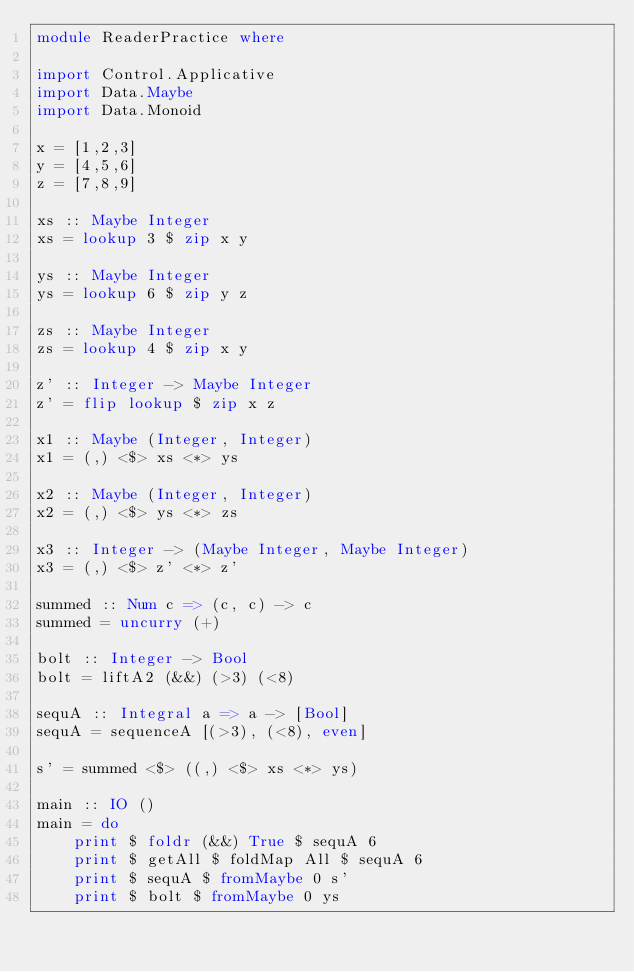<code> <loc_0><loc_0><loc_500><loc_500><_Haskell_>module ReaderPractice where

import Control.Applicative
import Data.Maybe
import Data.Monoid

x = [1,2,3]
y = [4,5,6]
z = [7,8,9]

xs :: Maybe Integer
xs = lookup 3 $ zip x y

ys :: Maybe Integer
ys = lookup 6 $ zip y z

zs :: Maybe Integer
zs = lookup 4 $ zip x y

z' :: Integer -> Maybe Integer
z' = flip lookup $ zip x z

x1 :: Maybe (Integer, Integer)
x1 = (,) <$> xs <*> ys

x2 :: Maybe (Integer, Integer)
x2 = (,) <$> ys <*> zs

x3 :: Integer -> (Maybe Integer, Maybe Integer)
x3 = (,) <$> z' <*> z'

summed :: Num c => (c, c) -> c
summed = uncurry (+)

bolt :: Integer -> Bool
bolt = liftA2 (&&) (>3) (<8)

sequA :: Integral a => a -> [Bool]
sequA = sequenceA [(>3), (<8), even]

s' = summed <$> ((,) <$> xs <*> ys)

main :: IO ()
main = do
    print $ foldr (&&) True $ sequA 6
    print $ getAll $ foldMap All $ sequA 6
    print $ sequA $ fromMaybe 0 s'
    print $ bolt $ fromMaybe 0 ys
</code> 